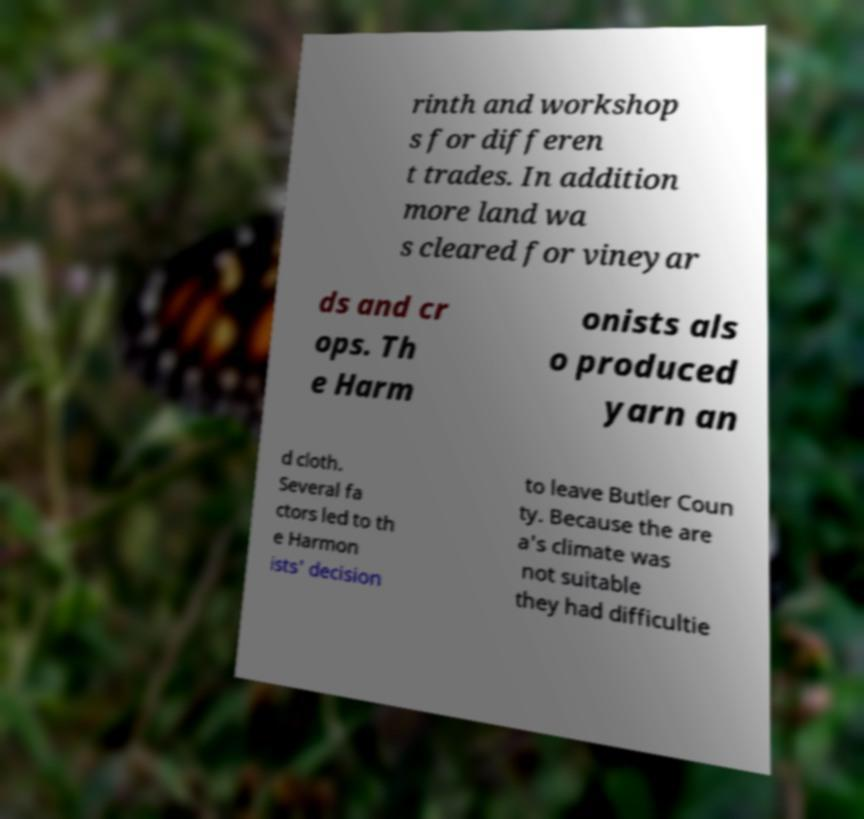For documentation purposes, I need the text within this image transcribed. Could you provide that? rinth and workshop s for differen t trades. In addition more land wa s cleared for vineyar ds and cr ops. Th e Harm onists als o produced yarn an d cloth. Several fa ctors led to th e Harmon ists' decision to leave Butler Coun ty. Because the are a's climate was not suitable they had difficultie 